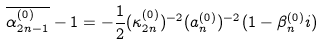<formula> <loc_0><loc_0><loc_500><loc_500>\overline { \alpha ^ { ( 0 ) } _ { 2 n - 1 } } - 1 = - \frac { 1 } { 2 } ( \kappa _ { 2 n } ^ { ( 0 ) } ) ^ { - 2 } ( a _ { n } ^ { ( 0 ) } ) ^ { - 2 } ( 1 - \beta _ { n } ^ { ( 0 ) } i )</formula> 